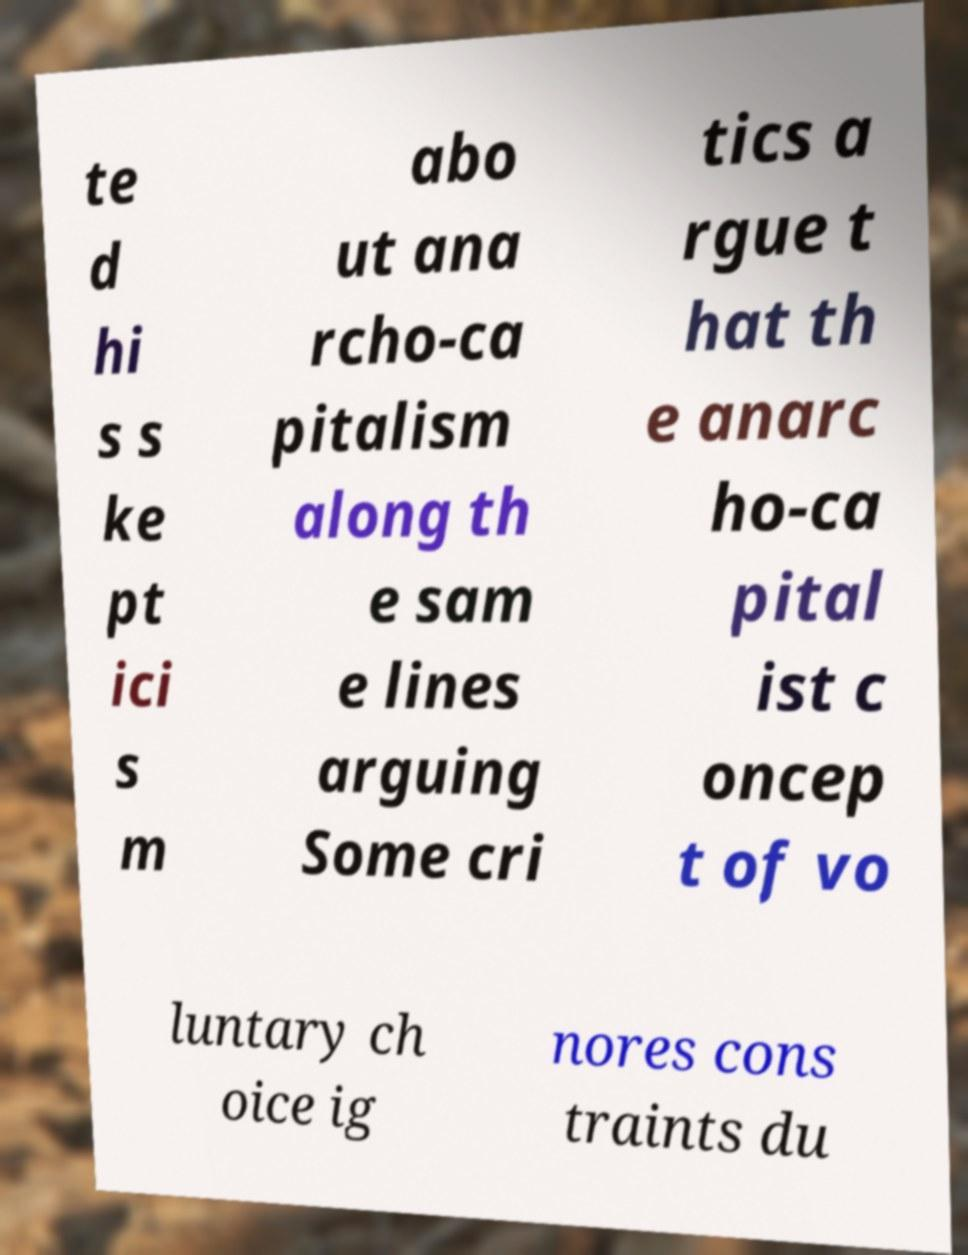There's text embedded in this image that I need extracted. Can you transcribe it verbatim? te d hi s s ke pt ici s m abo ut ana rcho-ca pitalism along th e sam e lines arguing Some cri tics a rgue t hat th e anarc ho-ca pital ist c oncep t of vo luntary ch oice ig nores cons traints du 